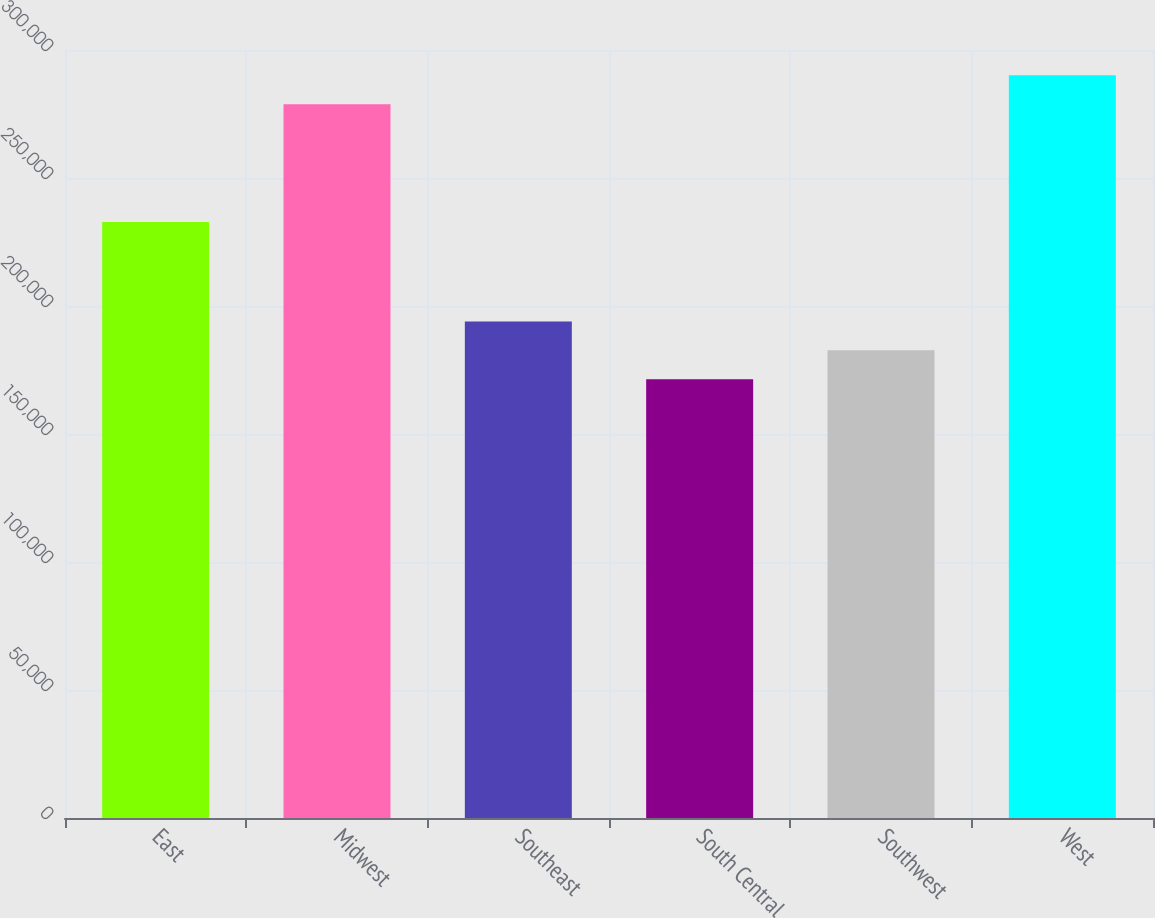Convert chart to OTSL. <chart><loc_0><loc_0><loc_500><loc_500><bar_chart><fcel>East<fcel>Midwest<fcel>Southeast<fcel>South Central<fcel>Southwest<fcel>West<nl><fcel>232800<fcel>278800<fcel>193980<fcel>171400<fcel>182690<fcel>290090<nl></chart> 